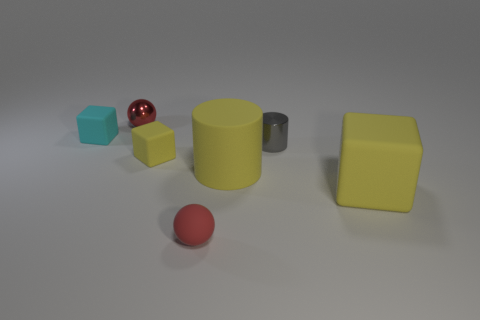There is a small red thing that is in front of the small block right of the tiny red shiny sphere that is on the right side of the cyan object; what shape is it?
Your answer should be compact. Sphere. What is the color of the thing that is on the right side of the cyan matte cube and behind the gray metal cylinder?
Offer a terse response. Red. What is the shape of the tiny thing that is right of the rubber ball?
Offer a very short reply. Cylinder. The large thing that is the same material as the big cylinder is what shape?
Provide a succinct answer. Cube. How many rubber objects are either blocks or tiny gray cylinders?
Keep it short and to the point. 3. What number of big objects are behind the yellow matte block that is to the left of the small rubber object in front of the big matte block?
Provide a succinct answer. 0. There is a thing that is in front of the big cube; does it have the same size as the cyan matte object that is left of the small yellow cube?
Provide a succinct answer. Yes. There is another tiny red object that is the same shape as the red rubber thing; what material is it?
Give a very brief answer. Metal. What number of tiny things are purple metallic balls or cyan matte cubes?
Your answer should be very brief. 1. What material is the cyan block?
Provide a short and direct response. Rubber. 